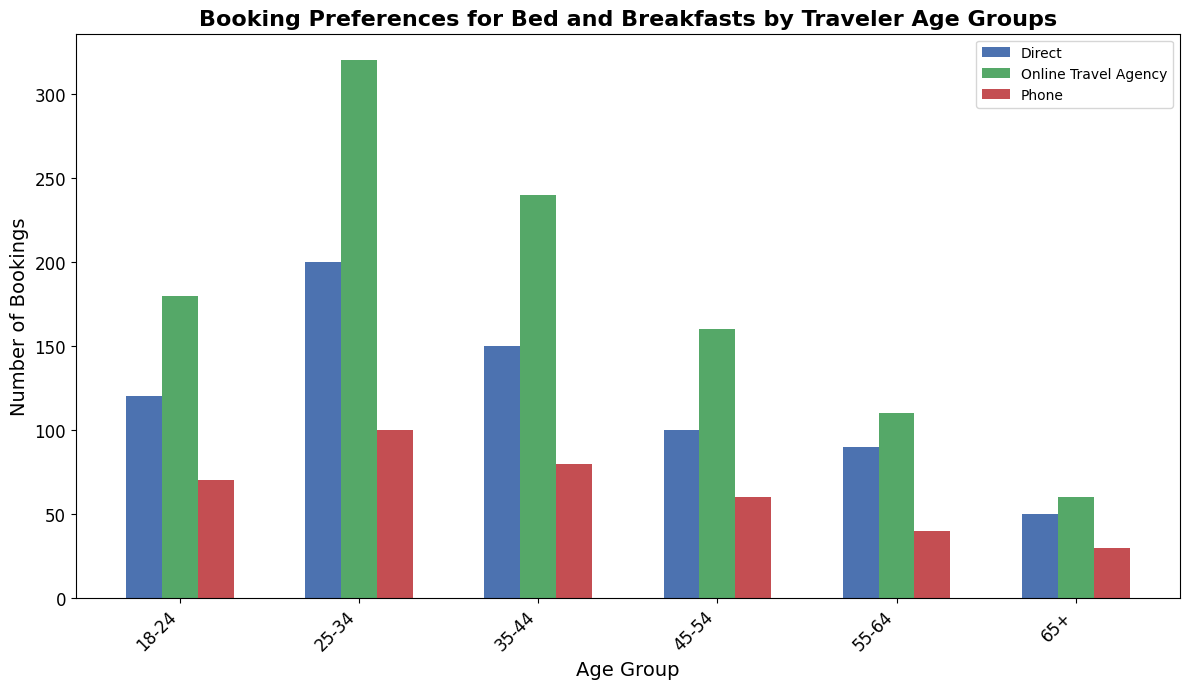Which age group has the highest number of direct bookings? Look at the height of the bars for direct bookings across all age groups. The 25-34 age group has the tallest bar for direct bookings.
Answer: 25-34 Which booking platform is preferred by the 18-24 age group? Compare the heights of the bars for the 18-24 age group. The bar for Online Travel Agency is the tallest.
Answer: Online Travel Agency How many total bookings are made by the 35-44 age group? Sum the heights of all bars for the 35-44 age group: 150 (Direct) + 240 (Online Travel Agency) + 80 (Phone).
Answer: 470 Is the number of phone bookings higher or lower than the number of direct bookings for the 55-64 age group? Compare the heights of the bars for Phone and Direct bookings in the 55-64 age group. The Direct bar is taller than the Phone bar.
Answer: Lower What is the difference in the number of online travel agency bookings between the 45-54 and 65+ age groups? Subtract the height of the Online Travel Agency bar for the 65+ age group from that for the 45-54 age group: 160 - 60.
Answer: 100 Which booking platform has the fewest preferences across all age groups? Compare the bars for each platform across all age groups. The Phone platform consistently has the shortest bars compared to Direct and Online Travel Agency.
Answer: Phone Among the 25-34 age group, which two booking platforms combined have the same number of bookings as the Online Travel Agency? Check the heights of the bars for each platform and compare: The Direct (200) and Phone (100) combined equal 300, which matches the Online Travel Agency (320).
Answer: Direct and Phone What is the average number of bookings for the Direct platform across all age groups? Sum the heights of all Direct bars and divide by the number of age groups: (120 + 200 + 150 + 100 + 90 + 50) / 6.
Answer: 118.33 How does the number of online travel agency bookings change from the 25-34 age group to the 55-64 age group? Compare the heights of the Online Travel Agency bars for the 25-34 and 55-64 age groups: 320 decreases to 110.
Answer: Decreases 